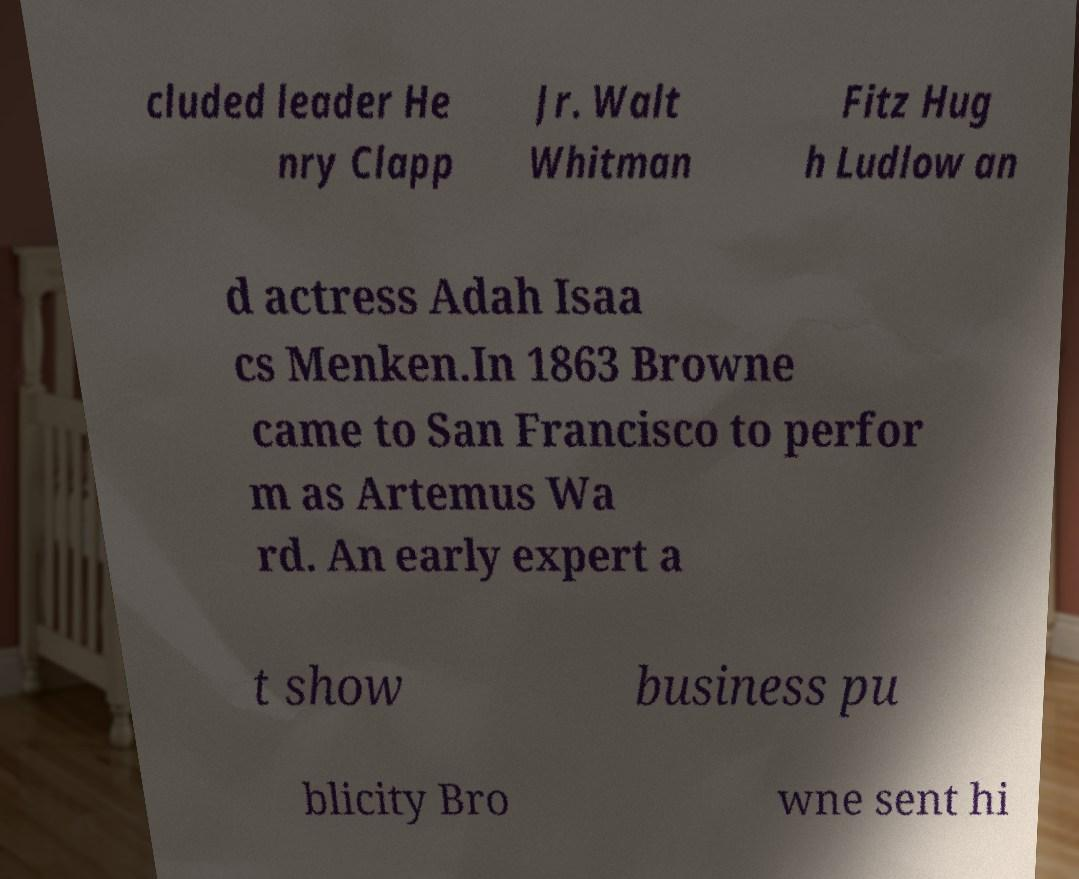I need the written content from this picture converted into text. Can you do that? cluded leader He nry Clapp Jr. Walt Whitman Fitz Hug h Ludlow an d actress Adah Isaa cs Menken.In 1863 Browne came to San Francisco to perfor m as Artemus Wa rd. An early expert a t show business pu blicity Bro wne sent hi 